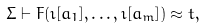<formula> <loc_0><loc_0><loc_500><loc_500>\Sigma \vdash F ( \imath [ a _ { 1 } ] , \dots , \imath [ a _ { m } ] ) \approx t ,</formula> 